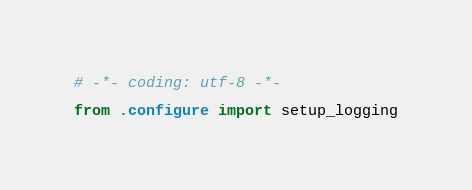Convert code to text. <code><loc_0><loc_0><loc_500><loc_500><_Python_># -*- coding: utf-8 -*-

from .configure import setup_logging
</code> 